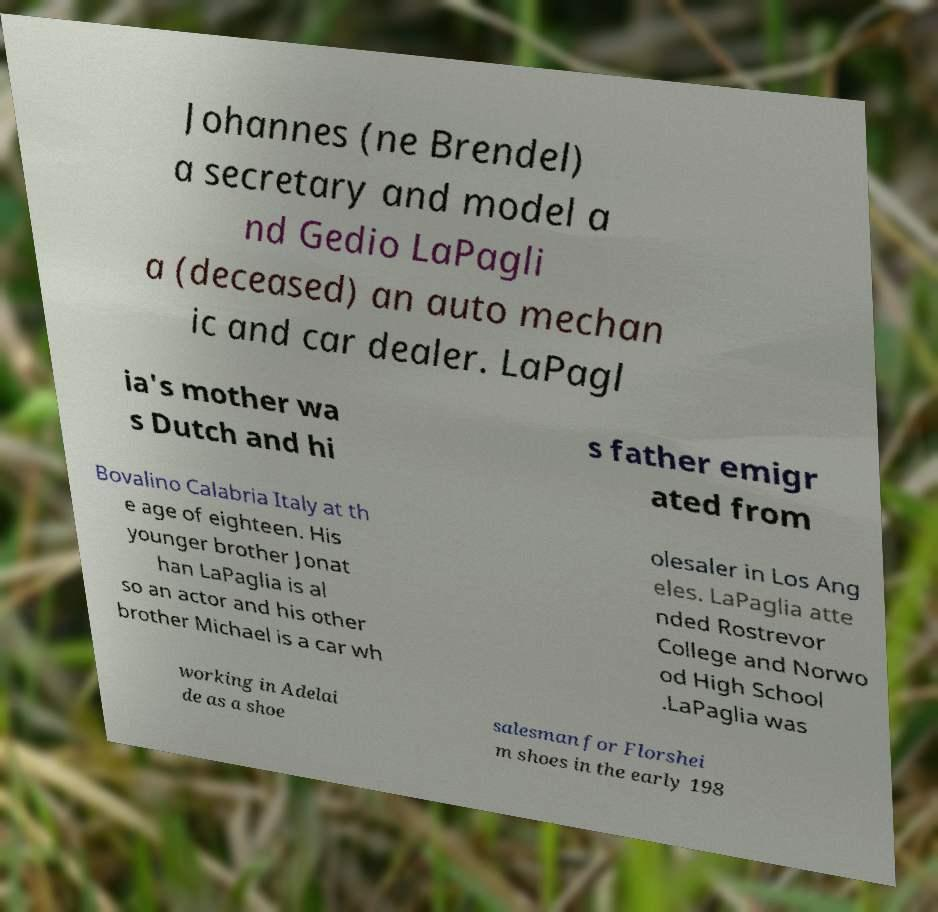For documentation purposes, I need the text within this image transcribed. Could you provide that? Johannes (ne Brendel) a secretary and model a nd Gedio LaPagli a (deceased) an auto mechan ic and car dealer. LaPagl ia's mother wa s Dutch and hi s father emigr ated from Bovalino Calabria Italy at th e age of eighteen. His younger brother Jonat han LaPaglia is al so an actor and his other brother Michael is a car wh olesaler in Los Ang eles. LaPaglia atte nded Rostrevor College and Norwo od High School .LaPaglia was working in Adelai de as a shoe salesman for Florshei m shoes in the early 198 